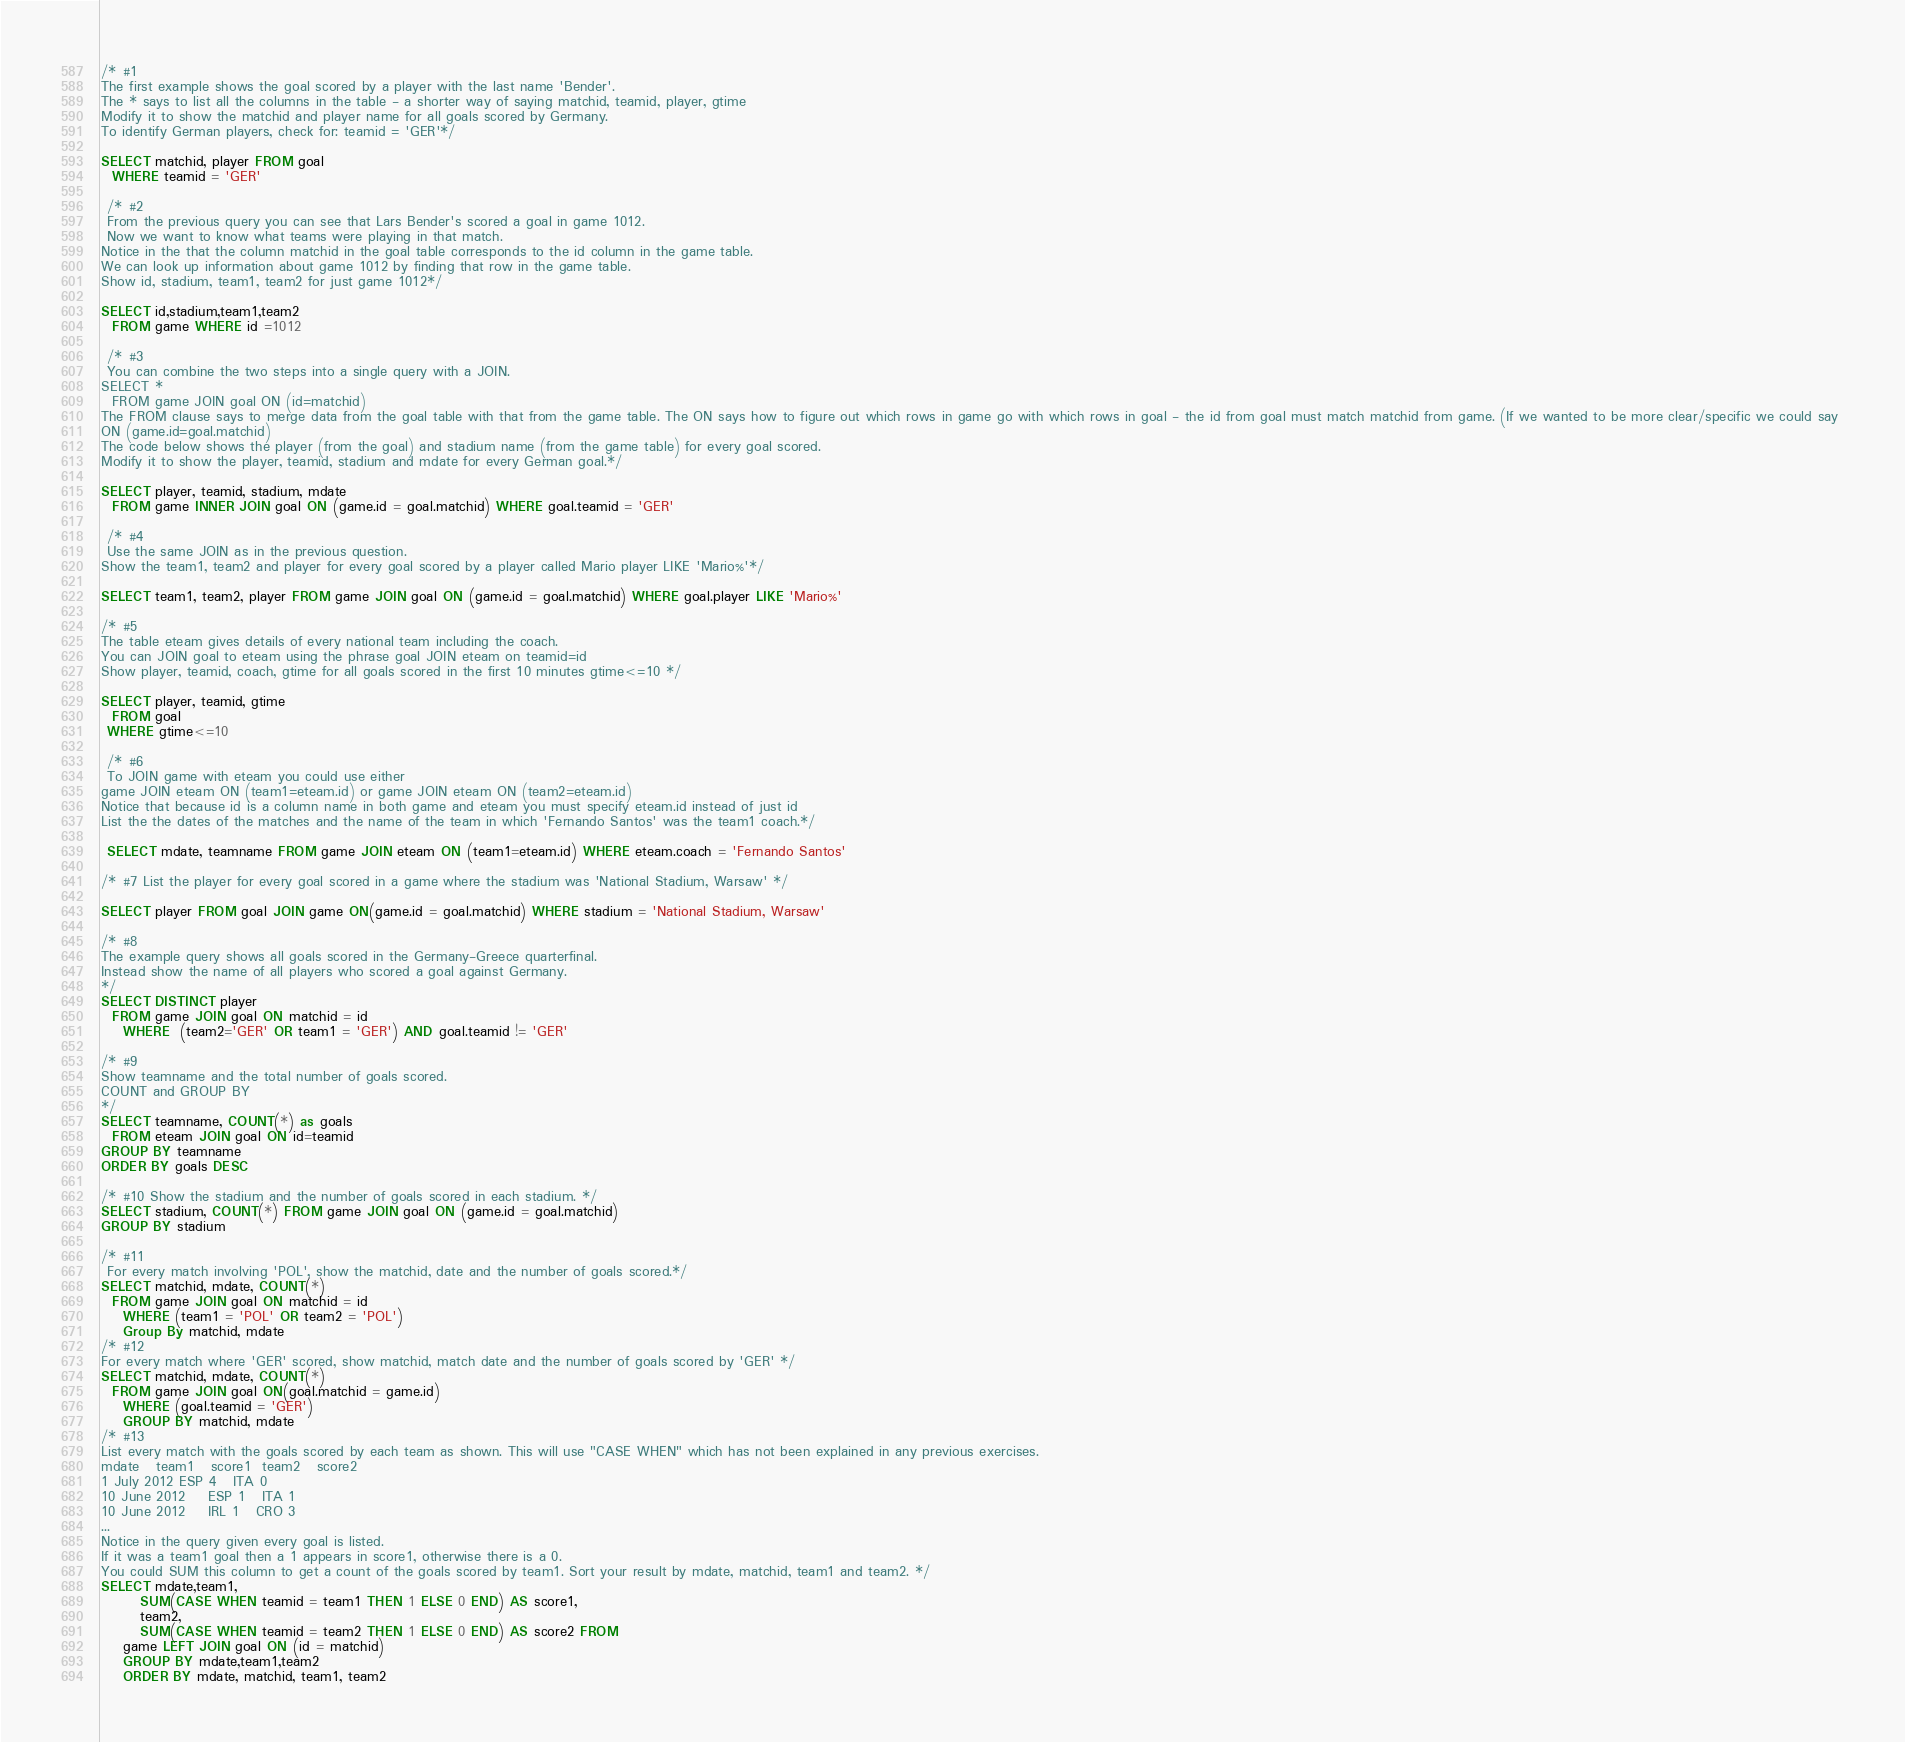Convert code to text. <code><loc_0><loc_0><loc_500><loc_500><_SQL_>
/* #1
The first example shows the goal scored by a player with the last name 'Bender'. 
The * says to list all the columns in the table - a shorter way of saying matchid, teamid, player, gtime
Modify it to show the matchid and player name for all goals scored by Germany.
To identify German players, check for: teamid = 'GER'*/

SELECT matchid, player FROM goal 
  WHERE teamid = 'GER'
 
 /* #2
 From the previous query you can see that Lars Bender's scored a goal in game 1012.
 Now we want to know what teams were playing in that match.
Notice in the that the column matchid in the goal table corresponds to the id column in the game table.
We can look up information about game 1012 by finding that row in the game table.
Show id, stadium, team1, team2 for just game 1012*/

SELECT id,stadium,team1,team2
  FROM game WHERE id =1012
  
 /* #3
 You can combine the two steps into a single query with a JOIN.
SELECT *
  FROM game JOIN goal ON (id=matchid)
The FROM clause says to merge data from the goal table with that from the game table. The ON says how to figure out which rows in game go with which rows in goal - the id from goal must match matchid from game. (If we wanted to be more clear/specific we could say 
ON (game.id=goal.matchid)
The code below shows the player (from the goal) and stadium name (from the game table) for every goal scored.
Modify it to show the player, teamid, stadium and mdate for every German goal.*/

SELECT player, teamid, stadium, mdate 
  FROM game INNER JOIN goal ON (game.id = goal.matchid) WHERE goal.teamid = 'GER'
 
 /* #4
 Use the same JOIN as in the previous question.
Show the team1, team2 and player for every goal scored by a player called Mario player LIKE 'Mario%'*/ 

SELECT team1, team2, player FROM game JOIN goal ON (game.id = goal.matchid) WHERE goal.player LIKE 'Mario%'

/* #5
The table eteam gives details of every national team including the coach.
You can JOIN goal to eteam using the phrase goal JOIN eteam on teamid=id
Show player, teamid, coach, gtime for all goals scored in the first 10 minutes gtime<=10 */

SELECT player, teamid, gtime
  FROM goal 
 WHERE gtime<=10
 
 /* #6
 To JOIN game with eteam you could use either
game JOIN eteam ON (team1=eteam.id) or game JOIN eteam ON (team2=eteam.id)
Notice that because id is a column name in both game and eteam you must specify eteam.id instead of just id
List the the dates of the matches and the name of the team in which 'Fernando Santos' was the team1 coach.*/

 SELECT mdate, teamname FROM game JOIN eteam ON (team1=eteam.id) WHERE eteam.coach = 'Fernando Santos'

/* #7 List the player for every goal scored in a game where the stadium was 'National Stadium, Warsaw' */

SELECT player FROM goal JOIN game ON(game.id = goal.matchid) WHERE stadium = 'National Stadium, Warsaw'

/* #8
The example query shows all goals scored in the Germany-Greece quarterfinal.
Instead show the name of all players who scored a goal against Germany.
*/
SELECT DISTINCT player
  FROM game JOIN goal ON matchid = id 
    WHERE  (team2='GER' OR team1 = 'GER') AND goal.teamid != 'GER'
    
/* #9
Show teamname and the total number of goals scored.
COUNT and GROUP BY
*/
SELECT teamname, COUNT(*) as goals
  FROM eteam JOIN goal ON id=teamid
GROUP BY teamname
ORDER BY goals DESC

/* #10 Show the stadium and the number of goals scored in each stadium. */
SELECT stadium, COUNT(*) FROM game JOIN goal ON (game.id = goal.matchid)
GROUP BY stadium

/* #11
 For every match involving 'POL', show the matchid, date and the number of goals scored.*/
SELECT matchid, mdate, COUNT(*)
  FROM game JOIN goal ON matchid = id 
    WHERE (team1 = 'POL' OR team2 = 'POL')
    Group By matchid, mdate
/* #12 
For every match where 'GER' scored, show matchid, match date and the number of goals scored by 'GER' */
SELECT matchid, mdate, COUNT(*)
  FROM game JOIN goal ON(goal.matchid = game.id)
    WHERE (goal.teamid = 'GER')
    GROUP BY matchid, mdate
/* #13
List every match with the goals scored by each team as shown. This will use "CASE WHEN" which has not been explained in any previous exercises.
mdate	team1	score1	team2	score2
1 July 2012	ESP	4	ITA	0
10 June 2012	ESP	1	ITA	1
10 June 2012	IRL	1	CRO	3
...
Notice in the query given every goal is listed.
If it was a team1 goal then a 1 appears in score1, otherwise there is a 0.
You could SUM this column to get a count of the goals scored by team1. Sort your result by mdate, matchid, team1 and team2. */
SELECT mdate,team1,
       SUM(CASE WHEN teamid = team1 THEN 1 ELSE 0 END) AS score1,
       team2,
       SUM(CASE WHEN teamid = team2 THEN 1 ELSE 0 END) AS score2 FROM
    game LEFT JOIN goal ON (id = matchid)
    GROUP BY mdate,team1,team2
    ORDER BY mdate, matchid, team1, team2
</code> 